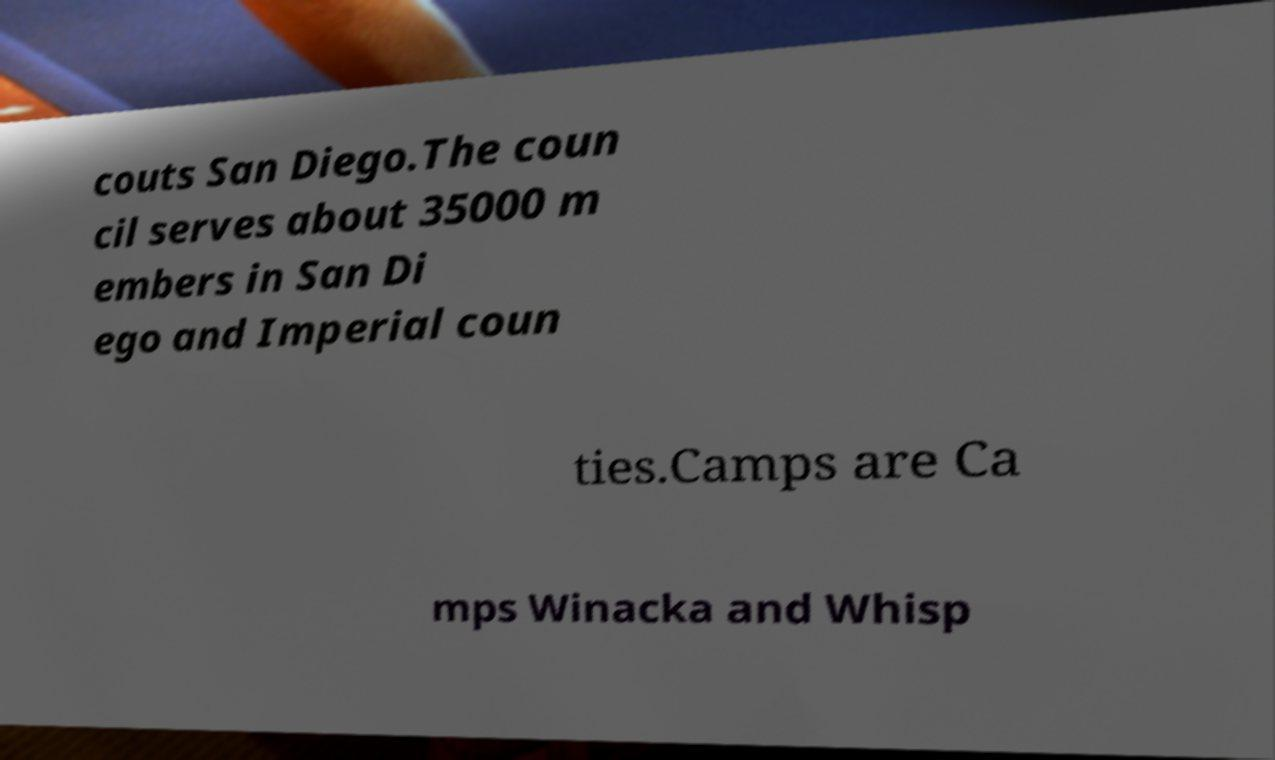What messages or text are displayed in this image? I need them in a readable, typed format. couts San Diego.The coun cil serves about 35000 m embers in San Di ego and Imperial coun ties.Camps are Ca mps Winacka and Whisp 